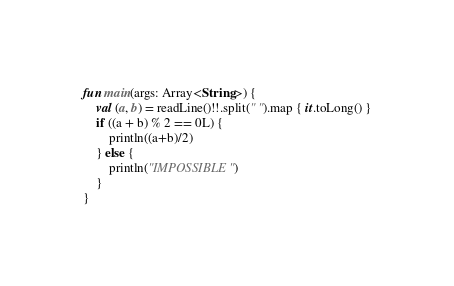<code> <loc_0><loc_0><loc_500><loc_500><_Kotlin_>fun main(args: Array<String>) {
    val (a, b) = readLine()!!.split(" ").map { it.toLong() }
    if ((a + b) % 2 == 0L) {
        println((a+b)/2)
    } else {
        println("IMPOSSIBLE")
    }
}</code> 